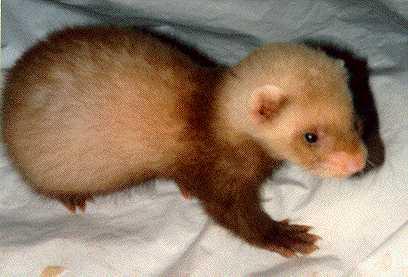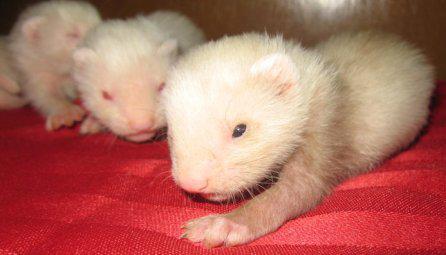The first image is the image on the left, the second image is the image on the right. For the images displayed, is the sentence "The single ferret on the left hand side is dressed up with an accessory while the right hand image shows exactly two ferrets." factually correct? Answer yes or no. No. The first image is the image on the left, the second image is the image on the right. For the images displayed, is the sentence "The animal in the image on the left is wearing an article of clothing." factually correct? Answer yes or no. No. 